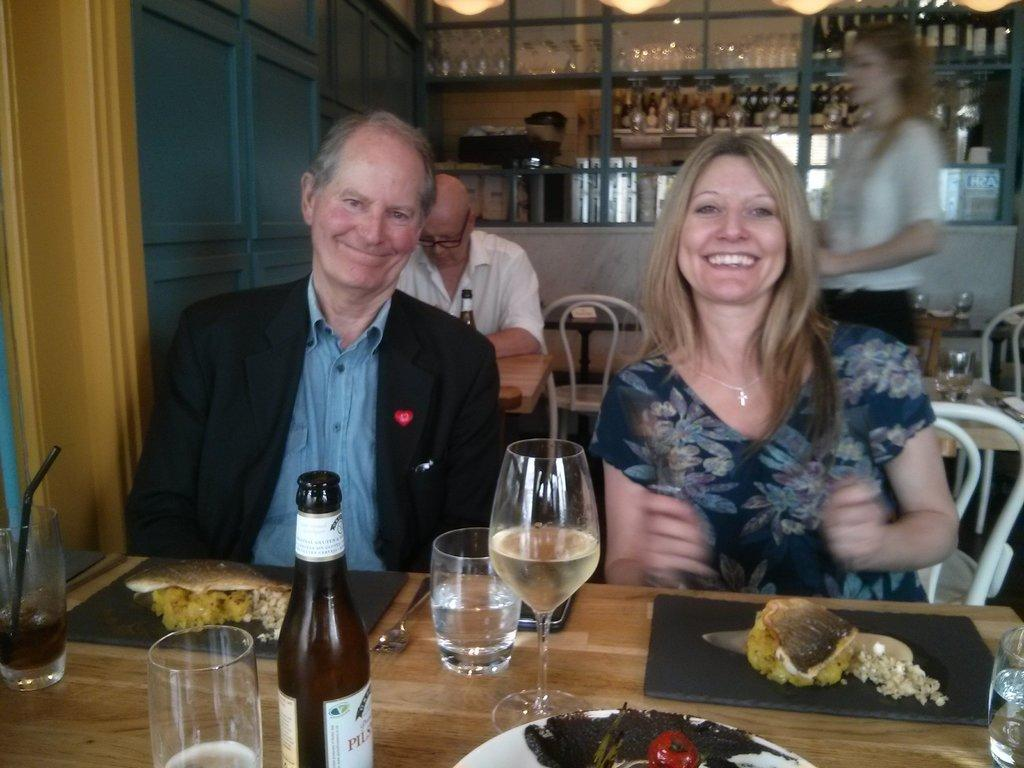What type of location is depicted in the image? The image depicts a restaurant setting. What are the people in the image doing? There are people seated in the restaurant, which suggests they are dining or waiting for their meal. What can be seen about the women in the image? There are women standing in the restaurant, possibly serving or attending to the guests. What type of beverages are present on the table? Wine bottles are present on the table, indicating that wine might be served in the restaurant. What else is visible on the table besides wine bottles? There are bottles on the table, which could contain other beverages or condiments. What might be served as part of the meal in the image? Food is visible on the table, suggesting that the people in the restaurant are being served a meal. What type of roll can be seen bursting out of the wine bottle in the image? There is no roll present in the image, nor is there any indication of a roll bursting out of a wine bottle. 